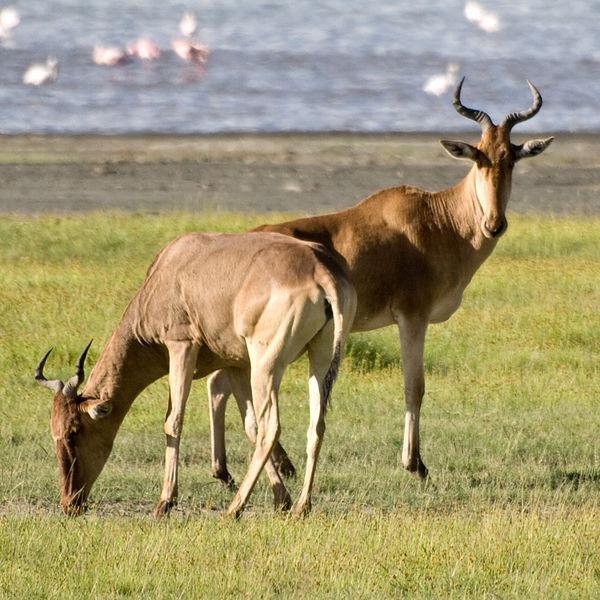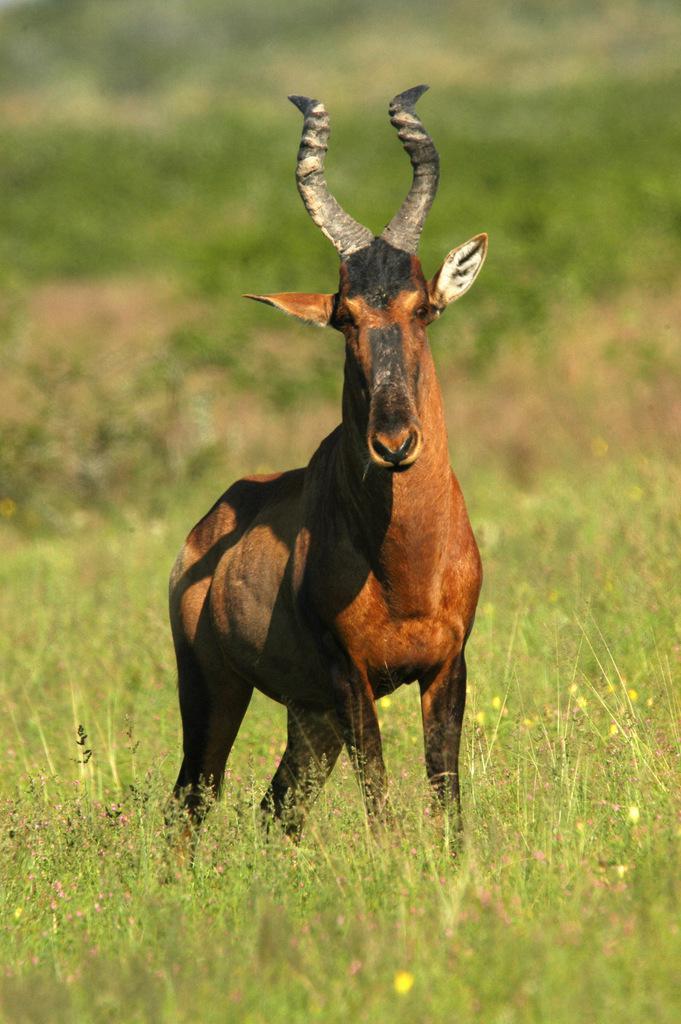The first image is the image on the left, the second image is the image on the right. Evaluate the accuracy of this statement regarding the images: "There are four ruminant animals (antelope types).". Is it true? Answer yes or no. No. The first image is the image on the left, the second image is the image on the right. Analyze the images presented: Is the assertion "Left image contains one horned animal, which is eyeing the camera, with its body turned rightward." valid? Answer yes or no. No. 